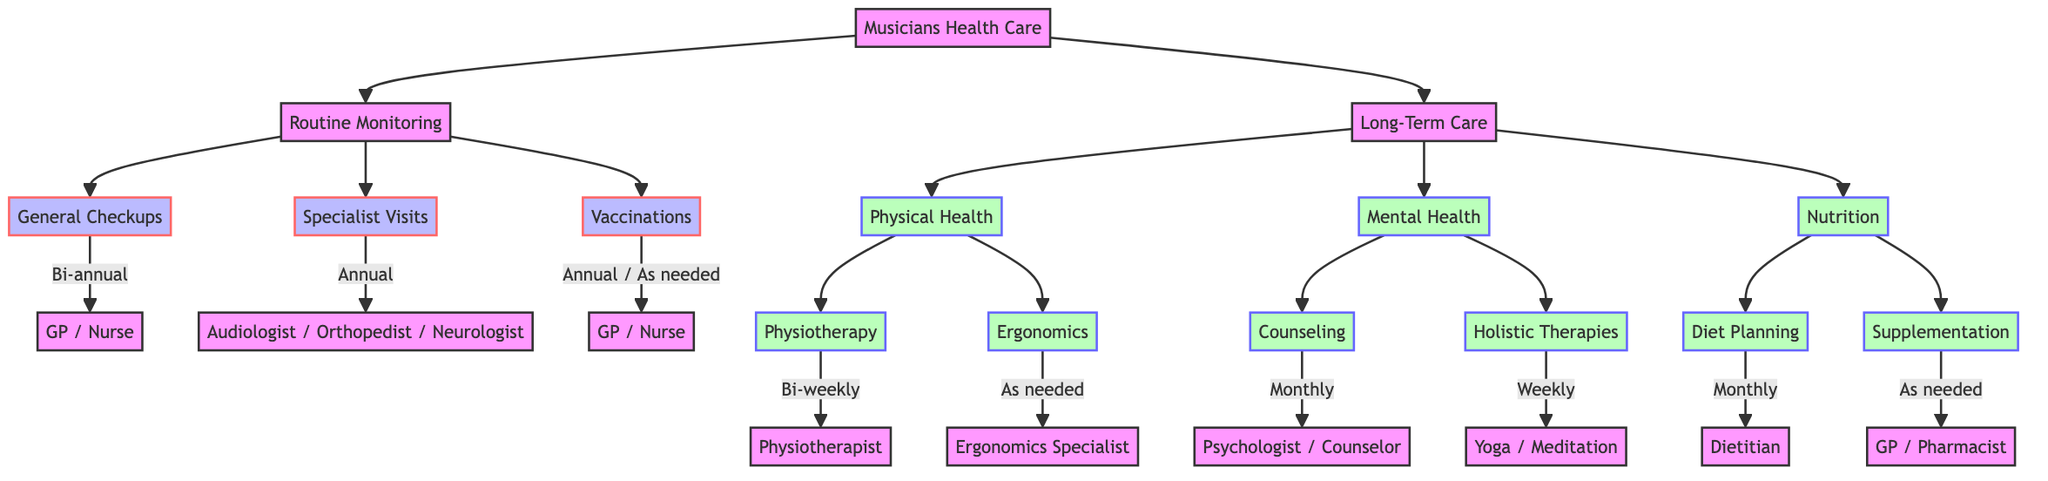What is the frequency of general checkups? The diagram indicates that general checkups occur bi-annually. This is stated directly under the 'General Checkups' node in the Routine Monitoring section.
Answer: Bi-annual How many types of specialist visits are listed? The diagram shows three specific types of specialist visits: Audiologist, Orthopedist, and Neurologist. Counting these categories directly gives us the total.
Answer: 3 What entities are involved in vaccinations? The diagram specifies that vaccinations are administered by both the GP and Nurse. This is mentioned under the 'Vaccinations' node in the Routine Monitoring section.
Answer: GP, Nurse What is the importance of physiotherapy in long-term care? The importance of physiotherapy is stated as maintaining musculoskeletal health, which is clearly documented in the 'Physiotherapy' node under the Physical Health section.
Answer: Maintain musculoskeletal health What is the frequency of counseling for mental health? According to the diagram, counseling is conducted monthly. This information is related specifically to the 'Counseling' node in the Mental Health section of Long-Term Care.
Answer: Monthly Which professional is involved in diet planning? The diagram indicates that a Dietitian is responsible for diet planning, which is explicitly mentioned under the 'Diet Planning' node within the Nutrition section.
Answer: Dietitian How frequently is holistic therapy recommended? The diagram shows that holistic therapies are recommended weekly. This information is found in the 'Holistic Therapies' node under the Mental Health section.
Answer: Weekly What is required for supplementation? The diagram states that supplementation is given as needed, mainly involving Vitamin D and Omega-3 Fatty Acids. This is detailed under the 'Supplementation' node within the Nutrition section.
Answer: As needed How often should physiotherapy sessions be held? The diagram specifies that physiotherapy should occur bi-weekly. This frequency is mentioned underneath the 'Physiotherapy' node in the Physical Health part of Long-Term Care.
Answer: Bi-weekly What health aspects does the long-term care include? The diagram indicates that Long-Term Care covers Physical Health, Mental Health, and Nutrition. These categories are listed as the main branches under Long-Term Care.
Answer: Physical Health, Mental Health, Nutrition 